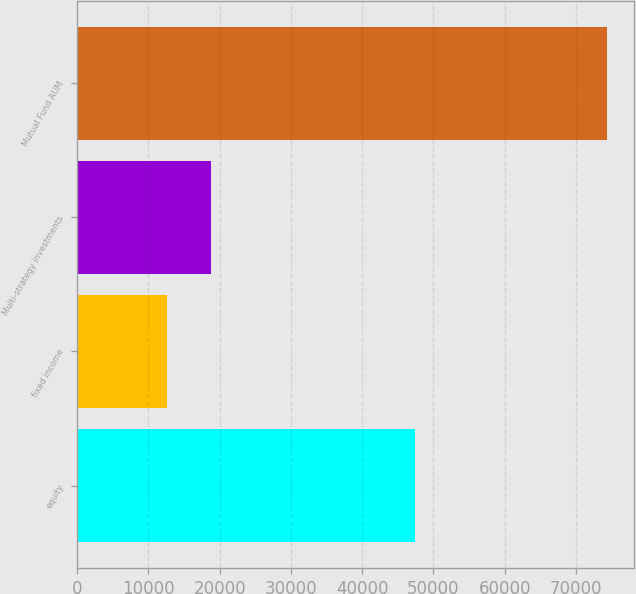Convert chart to OTSL. <chart><loc_0><loc_0><loc_500><loc_500><bar_chart><fcel>equity<fcel>fixed income<fcel>Multi-strategy investments<fcel>Mutual Fund AUM<nl><fcel>47369<fcel>12625<fcel>18803.8<fcel>74413<nl></chart> 